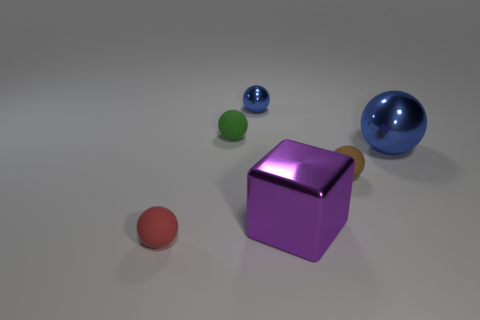Subtract all small balls. How many balls are left? 1 Subtract all red balls. How many balls are left? 4 Subtract all cubes. How many objects are left? 5 Subtract 3 spheres. How many spheres are left? 2 Add 5 purple things. How many purple things exist? 6 Add 1 small blue shiny spheres. How many objects exist? 7 Subtract 1 brown balls. How many objects are left? 5 Subtract all gray spheres. Subtract all blue cylinders. How many spheres are left? 5 Subtract all brown cylinders. How many gray blocks are left? 0 Subtract all brown balls. Subtract all small things. How many objects are left? 1 